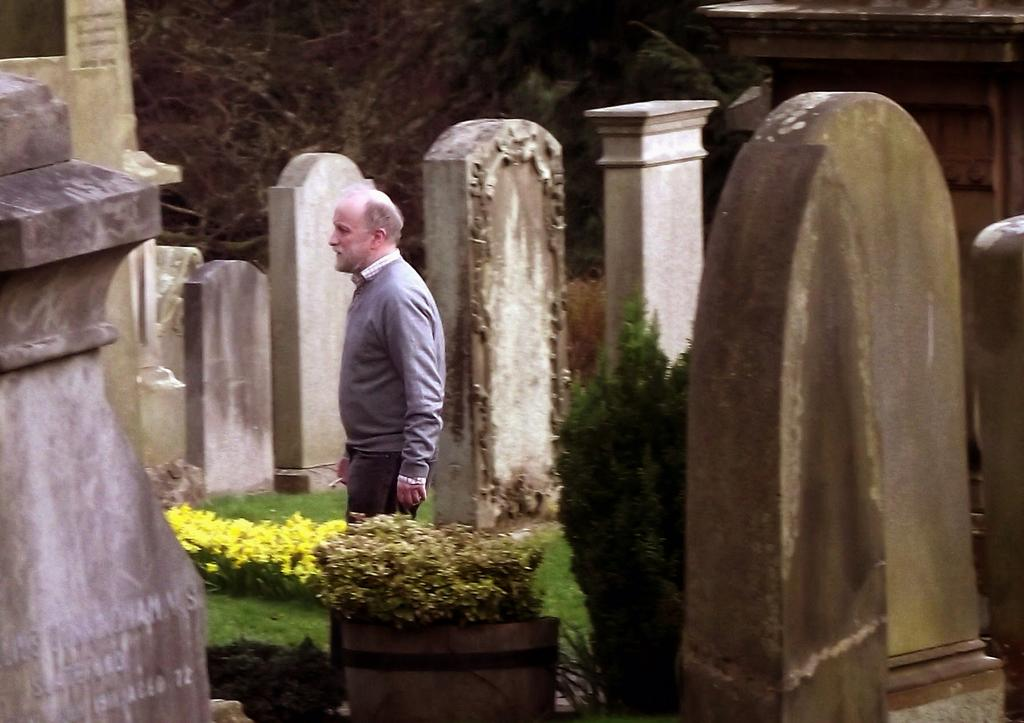What is the man in the image doing? The man is standing on the ground in the image. What type of natural elements can be seen in the image? There are flowers, trees, and gravestones visible in the image. What else is present on the ground in the image? There are other objects on the ground in the image. What type of crib can be seen in the image? There is no crib present in the image. How many shoes are visible on the ground in the image? There is no mention of shoes in the image; it features a man standing on the ground, flowers, trees, gravestones, and other objects. 